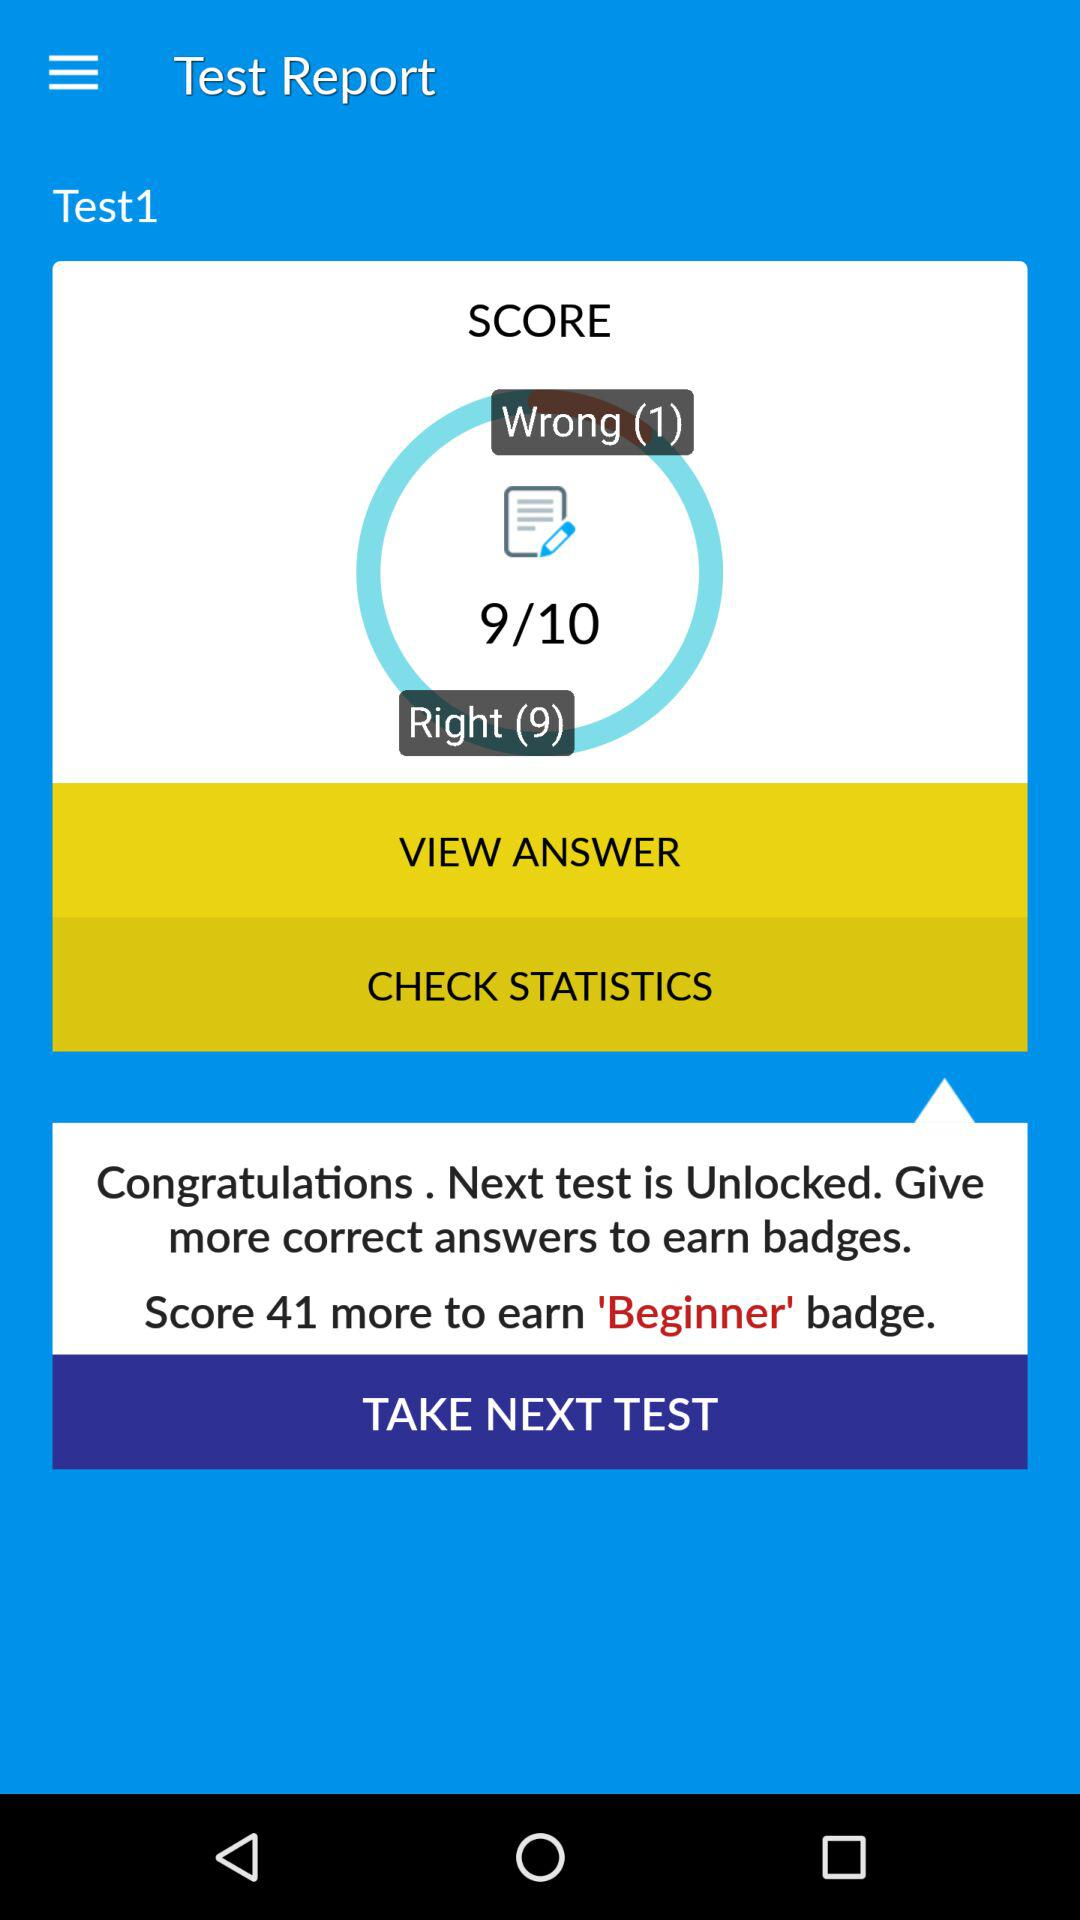What is the total score of all correct answers?
Answer the question using a single word or phrase. 9 